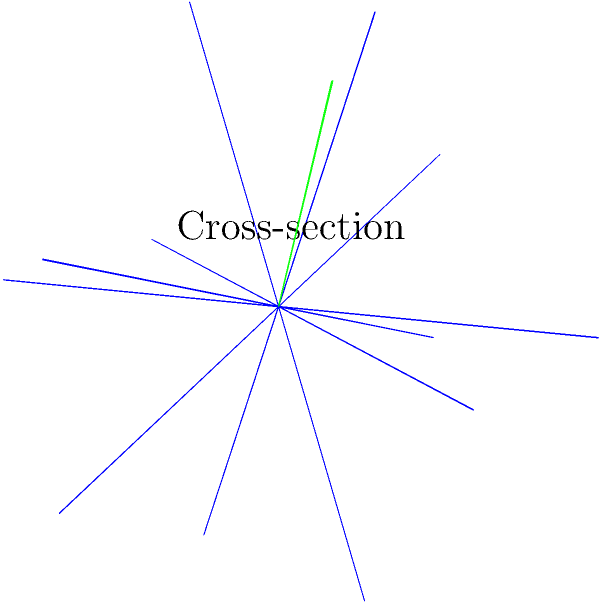In the spirit of avant-garde jazz, consider a stellated dodecahedron – an unconventional geometric solid. If we were to slice this shape with a plane perpendicular to the vector $\mathbf{v} = (1,1,1)$ and passing through the point $(0.5, 0.5, 0.5)$, what would be the most likely shape of the resulting cross-section? Let's break this down step-by-step, like analyzing a complex jazz composition:

1) A stellated dodecahedron is formed by extending the faces of a regular dodecahedron until they meet, creating a star-like shape with 60 triangular faces.

2) The cross-section of any polyhedron depends on the angle and position of the cutting plane relative to the solid's symmetry.

3) The vector $\mathbf{v} = (1,1,1)$ is perpendicular to our cutting plane and passes through the point $(0.5, 0.5, 0.5)$, which is relatively close to the center of the solid.

4) This vector is symmetrically oriented with respect to the stellated dodecahedron, as it passes through the center and points towards one of the vertices.

5) Given this symmetry, the cross-section is likely to be a regular polygon.

6) The stellated dodecahedron has icosahedral symmetry, which includes 5-fold rotational symmetry axes.

7) When a plane perpendicular to a 5-fold symmetry axis intersects a stellated dodecahedron near its center, it typically produces a regular decagon (10-sided polygon).

8) The exact shape might vary slightly depending on the precise position of the plane, but a decagon is the most likely regular polygon to appear in this scenario.
Answer: Regular decagon 